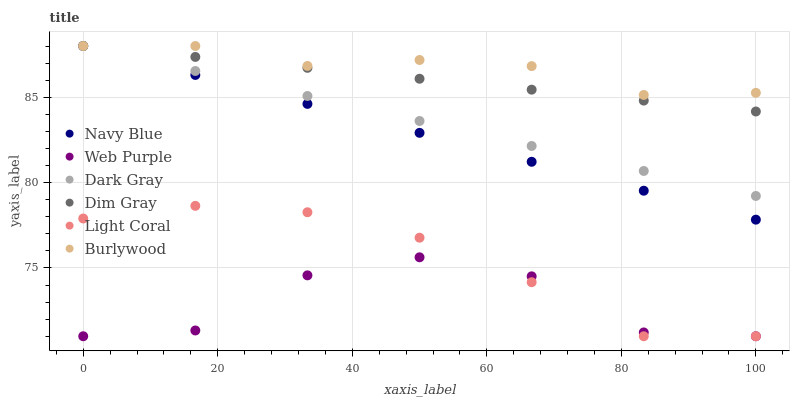Does Web Purple have the minimum area under the curve?
Answer yes or no. Yes. Does Burlywood have the maximum area under the curve?
Answer yes or no. Yes. Does Dim Gray have the minimum area under the curve?
Answer yes or no. No. Does Dim Gray have the maximum area under the curve?
Answer yes or no. No. Is Navy Blue the smoothest?
Answer yes or no. Yes. Is Web Purple the roughest?
Answer yes or no. Yes. Is Dim Gray the smoothest?
Answer yes or no. No. Is Dim Gray the roughest?
Answer yes or no. No. Does Light Coral have the lowest value?
Answer yes or no. Yes. Does Dim Gray have the lowest value?
Answer yes or no. No. Does Dark Gray have the highest value?
Answer yes or no. Yes. Does Web Purple have the highest value?
Answer yes or no. No. Is Light Coral less than Burlywood?
Answer yes or no. Yes. Is Dim Gray greater than Light Coral?
Answer yes or no. Yes. Does Dim Gray intersect Navy Blue?
Answer yes or no. Yes. Is Dim Gray less than Navy Blue?
Answer yes or no. No. Is Dim Gray greater than Navy Blue?
Answer yes or no. No. Does Light Coral intersect Burlywood?
Answer yes or no. No. 